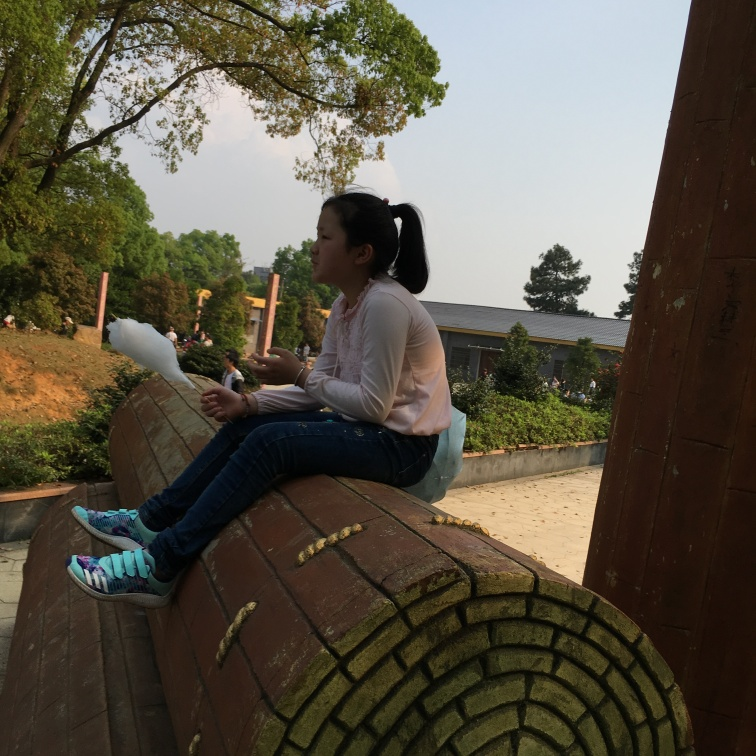Can you describe the setting and mood of this photo? The photo captures a serene, outdoor setting, likely in a park with lush greenery and a tranquil environment. The subject appears contemplative, possibly enjoying a peaceful moment alone. The soft, natural lighting adds to the relaxed mood, suggesting late afternoon or early evening. 